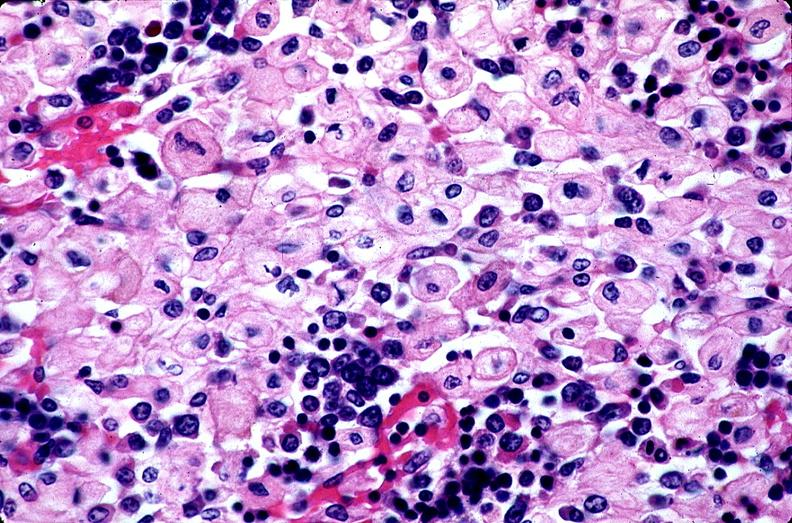s hematologic present?
Answer the question using a single word or phrase. Yes 